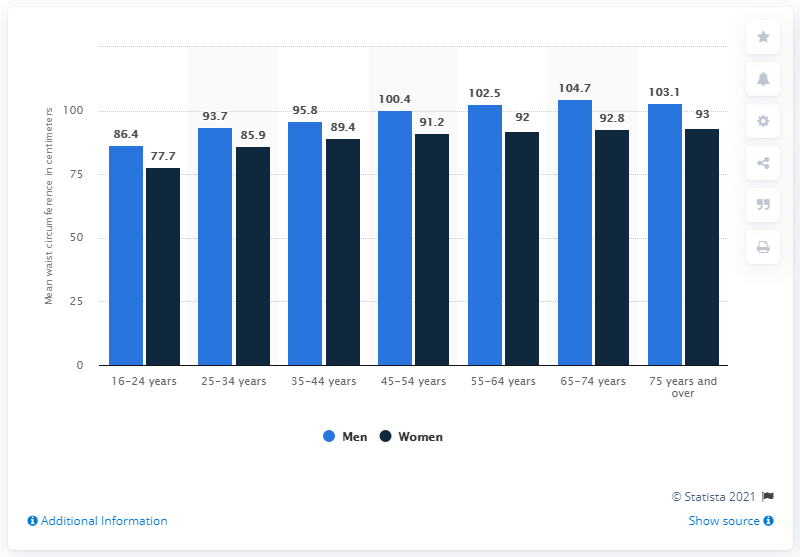Indicate a few pertinent items in this graphic. The use of gendered language, such as "men," to refer to a group of people is not appropriate in all contexts. It is important to use inclusive language that does not reinforce harmful gender stereotypes, such as using "people" or "individuals" instead of "men" or "women. The difference between the genders in the 16-24 years category is 8.7%. 